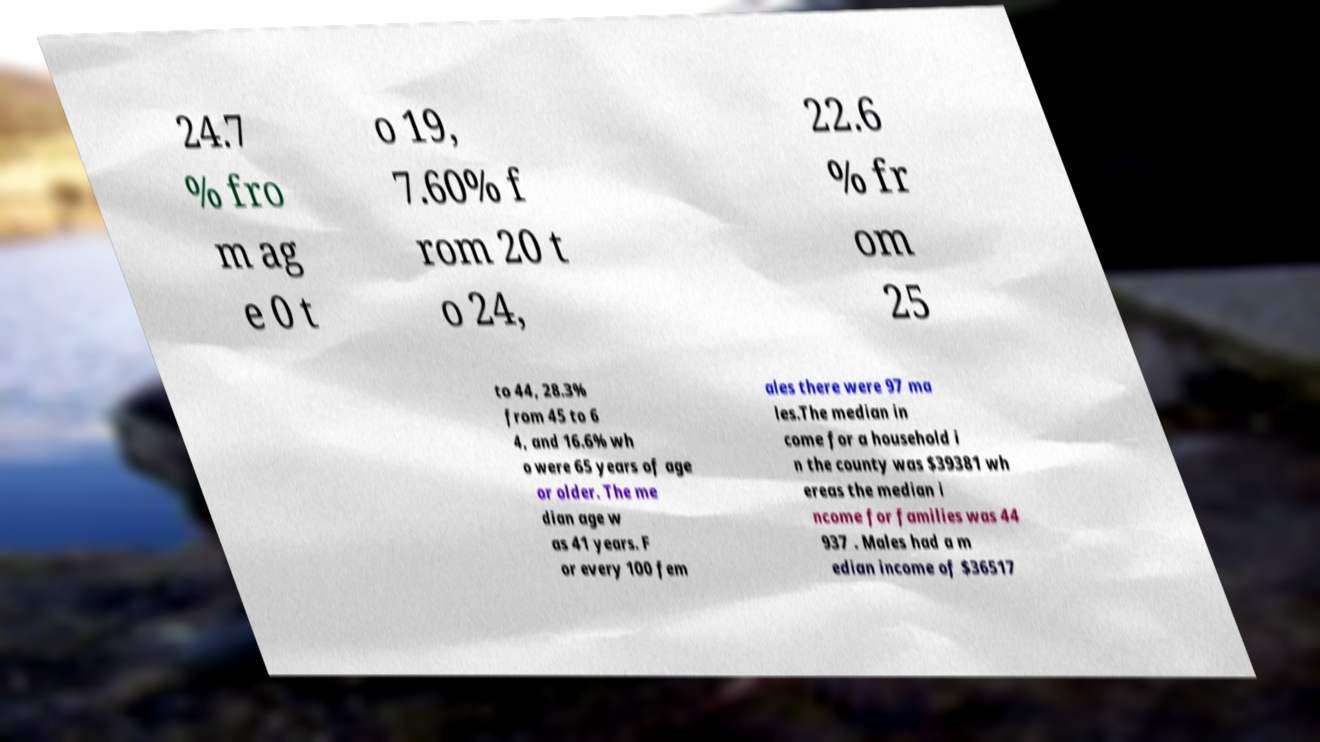Can you accurately transcribe the text from the provided image for me? 24.7 % fro m ag e 0 t o 19, 7.60% f rom 20 t o 24, 22.6 % fr om 25 to 44, 28.3% from 45 to 6 4, and 16.6% wh o were 65 years of age or older. The me dian age w as 41 years. F or every 100 fem ales there were 97 ma les.The median in come for a household i n the county was $39381 wh ereas the median i ncome for families was 44 937 . Males had a m edian income of $36517 